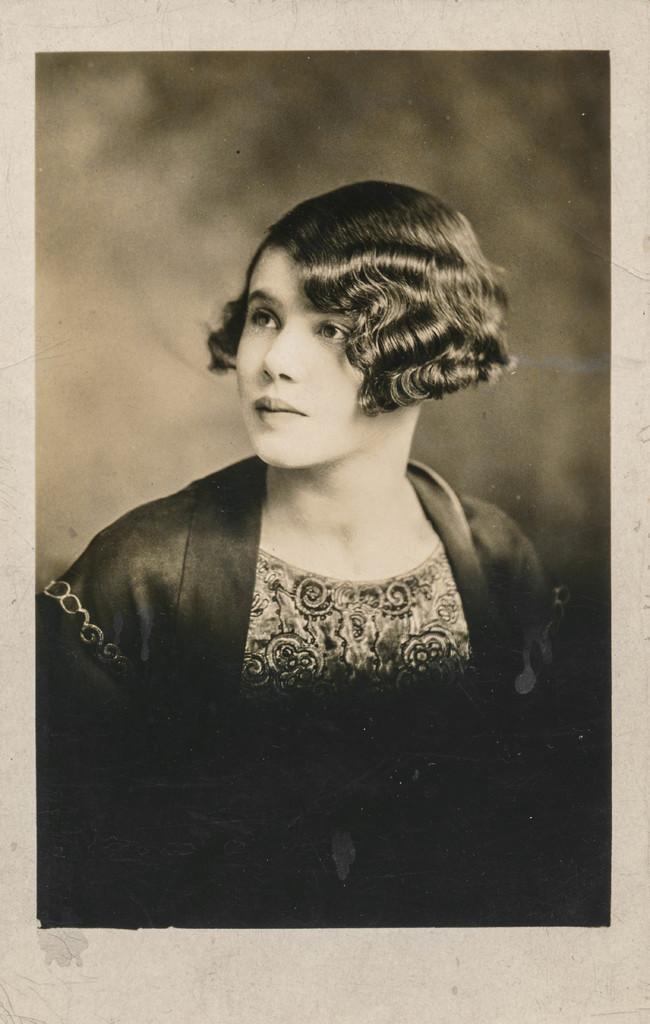What is the main subject of the image? The main subject of the image is a portrait of a woman. Can you describe the woman's hair in the portrait? The woman has short curly hair. What is the woman wearing in the portrait? The woman is wearing a black dress. How many cattle can be seen in the portrait? There are no cattle present in the portrait; it features a portrait of a woman. What type of rifle is the woman holding in the portrait? There is no rifle present in the portrait; it features a woman with short curly hair and a black dress. 